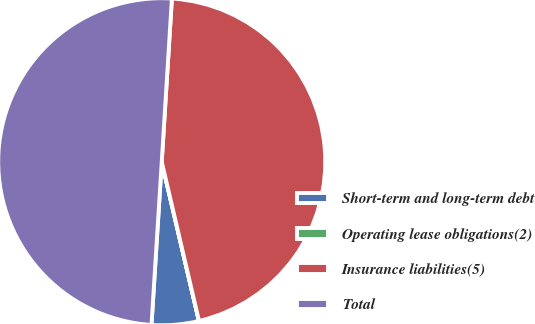<chart> <loc_0><loc_0><loc_500><loc_500><pie_chart><fcel>Short-term and long-term debt<fcel>Operating lease obligations(2)<fcel>Insurance liabilities(5)<fcel>Total<nl><fcel>4.65%<fcel>0.01%<fcel>45.35%<fcel>49.99%<nl></chart> 